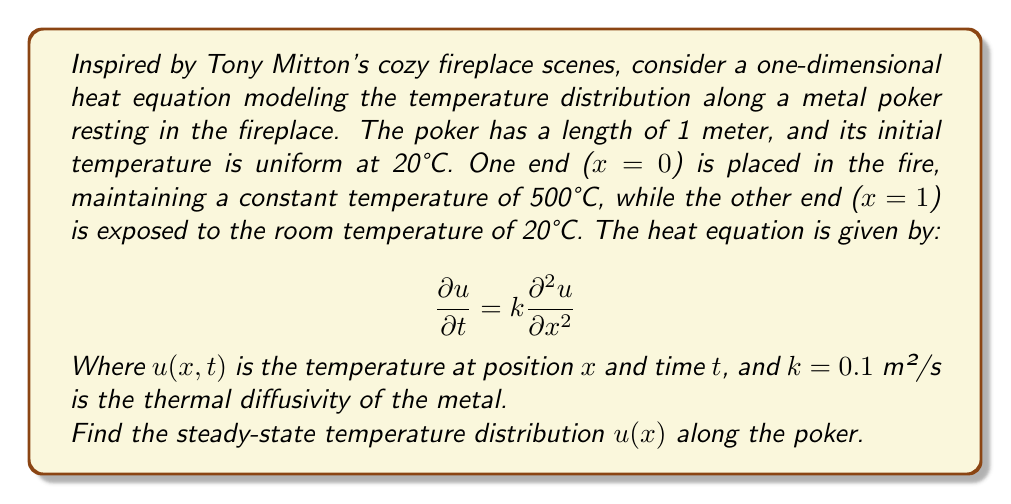Give your solution to this math problem. To solve this problem, we'll follow these steps:

1) For the steady-state solution, the temperature doesn't change with time, so $\frac{\partial u}{\partial t} = 0$. The heat equation becomes:

   $$0 = k\frac{d^2 u}{dx^2}$$

2) Integrating twice:

   $$\frac{du}{dx} = C_1$$
   $$u(x) = C_1x + C_2$$

3) Now we apply the boundary conditions:
   At $x = 0$, $u(0) = 500°C$
   At $x = 1$, $u(1) = 20°C$

4) Substituting these into our general solution:

   $500 = C_2$
   $20 = C_1 + C_2 = C_1 + 500$

5) Solving for $C_1$:

   $C_1 = 20 - 500 = -480$

6) Therefore, our steady-state solution is:

   $$u(x) = -480x + 500$$

This linear function describes how the temperature decreases along the length of the poker from the hot end in the fire to the cool end in the room.
Answer: The steady-state temperature distribution along the poker is given by:

$$u(x) = -480x + 500$$

Where $x$ is the distance along the poker in meters, and $u(x)$ is the temperature in °C at that point. 